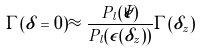Convert formula to latex. <formula><loc_0><loc_0><loc_500><loc_500>\Gamma ( \delta = 0 ) \approx \frac { P _ { l } ( \bar { \epsilon } ) } { P _ { l } ( \epsilon ( \delta _ { z } ) ) } \Gamma ( \delta _ { z } )</formula> 